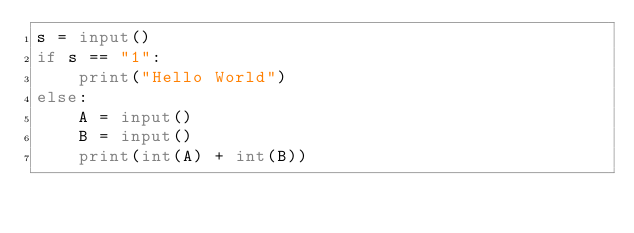<code> <loc_0><loc_0><loc_500><loc_500><_Python_>s = input()
if s == "1":
    print("Hello World")
else:
    A = input()
    B = input()
    print(int(A) + int(B))</code> 